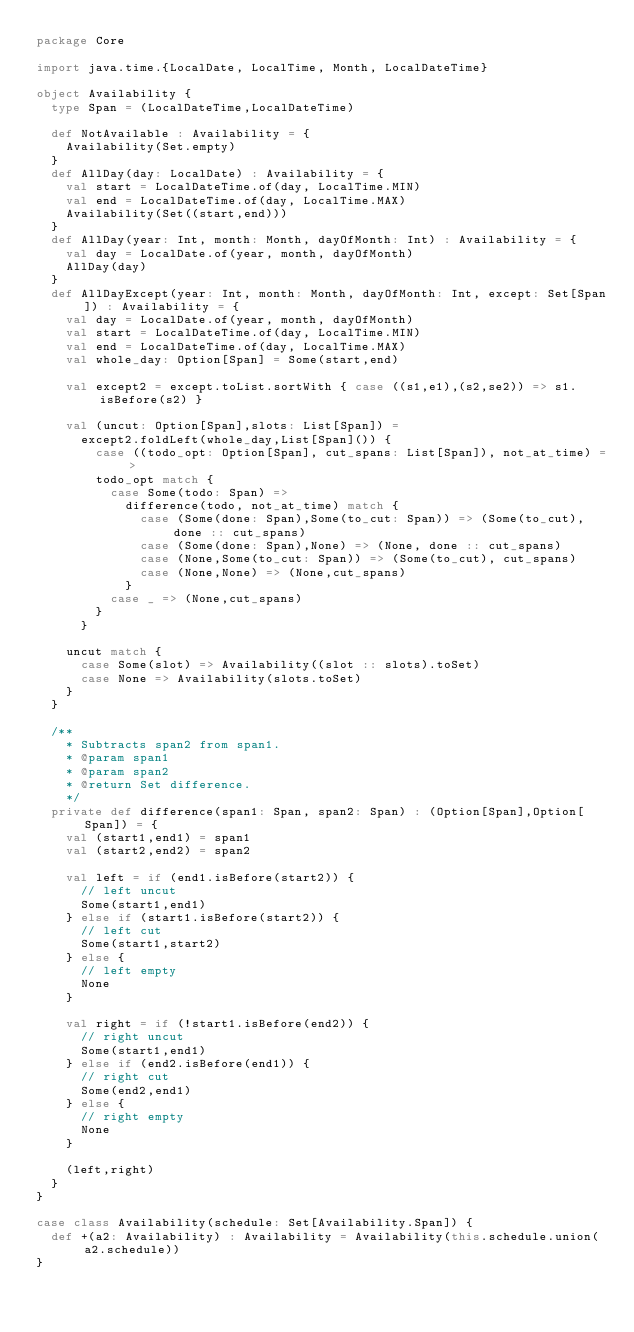Convert code to text. <code><loc_0><loc_0><loc_500><loc_500><_Scala_>package Core

import java.time.{LocalDate, LocalTime, Month, LocalDateTime}

object Availability {
  type Span = (LocalDateTime,LocalDateTime)

  def NotAvailable : Availability = {
    Availability(Set.empty)
  }
  def AllDay(day: LocalDate) : Availability = {
    val start = LocalDateTime.of(day, LocalTime.MIN)
    val end = LocalDateTime.of(day, LocalTime.MAX)
    Availability(Set((start,end)))
  }
  def AllDay(year: Int, month: Month, dayOfMonth: Int) : Availability = {
    val day = LocalDate.of(year, month, dayOfMonth)
    AllDay(day)
  }
  def AllDayExcept(year: Int, month: Month, dayOfMonth: Int, except: Set[Span]) : Availability = {
    val day = LocalDate.of(year, month, dayOfMonth)
    val start = LocalDateTime.of(day, LocalTime.MIN)
    val end = LocalDateTime.of(day, LocalTime.MAX)
    val whole_day: Option[Span] = Some(start,end)

    val except2 = except.toList.sortWith { case ((s1,e1),(s2,se2)) => s1.isBefore(s2) }

    val (uncut: Option[Span],slots: List[Span]) =
      except2.foldLeft(whole_day,List[Span]()) {
        case ((todo_opt: Option[Span], cut_spans: List[Span]), not_at_time) =>
        todo_opt match {
          case Some(todo: Span) =>
            difference(todo, not_at_time) match {
              case (Some(done: Span),Some(to_cut: Span)) => (Some(to_cut), done :: cut_spans)
              case (Some(done: Span),None) => (None, done :: cut_spans)
              case (None,Some(to_cut: Span)) => (Some(to_cut), cut_spans)
              case (None,None) => (None,cut_spans)
            }
          case _ => (None,cut_spans)
        }
      }

    uncut match {
      case Some(slot) => Availability((slot :: slots).toSet)
      case None => Availability(slots.toSet)
    }
  }

  /**
    * Subtracts span2 from span1.
    * @param span1
    * @param span2
    * @return Set difference.
    */
  private def difference(span1: Span, span2: Span) : (Option[Span],Option[Span]) = {
    val (start1,end1) = span1
    val (start2,end2) = span2

    val left = if (end1.isBefore(start2)) {
      // left uncut
      Some(start1,end1)
    } else if (start1.isBefore(start2)) {
      // left cut
      Some(start1,start2)
    } else {
      // left empty
      None
    }

    val right = if (!start1.isBefore(end2)) {
      // right uncut
      Some(start1,end1)
    } else if (end2.isBefore(end1)) {
      // right cut
      Some(end2,end1)
    } else {
      // right empty
      None
    }

    (left,right)
  }
}

case class Availability(schedule: Set[Availability.Span]) {
  def +(a2: Availability) : Availability = Availability(this.schedule.union(a2.schedule))
}
</code> 